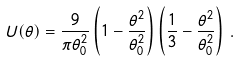Convert formula to latex. <formula><loc_0><loc_0><loc_500><loc_500>U ( \theta ) = \frac { 9 } { \pi \theta _ { 0 } ^ { 2 } } \left ( 1 - \frac { \theta ^ { 2 } } { \theta _ { 0 } ^ { 2 } } \right ) \left ( \frac { 1 } { 3 } - \frac { \theta ^ { 2 } } { \theta _ { 0 } ^ { 2 } } \right ) \, .</formula> 